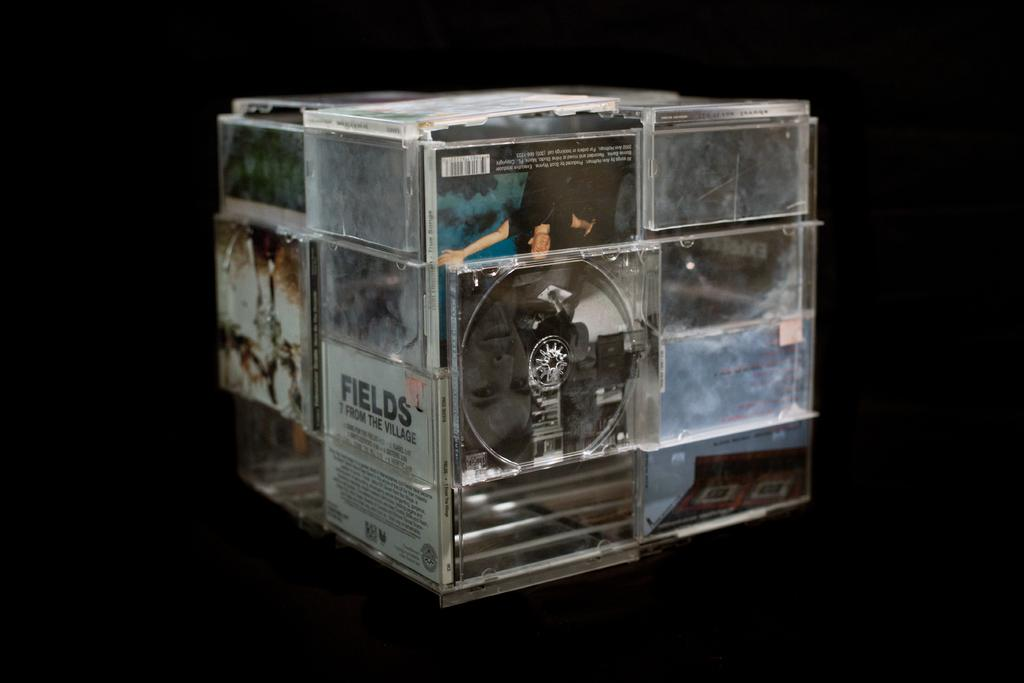<image>
Share a concise interpretation of the image provided. A plastic square cube is holding photos in many different small squares around the cube with one being a cd  called FIELDS. 